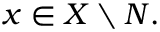<formula> <loc_0><loc_0><loc_500><loc_500>{ x \in X \ N } .</formula> 